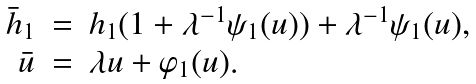Convert formula to latex. <formula><loc_0><loc_0><loc_500><loc_500>\begin{array} { r c l } \bar { h } _ { 1 } & = & h _ { 1 } ( 1 + \lambda ^ { - 1 } \psi _ { 1 } ( u ) ) + \lambda ^ { - 1 } \psi _ { 1 } ( u ) , \\ \bar { u } & = & \lambda u + \varphi _ { 1 } ( u ) . \end{array}</formula> 